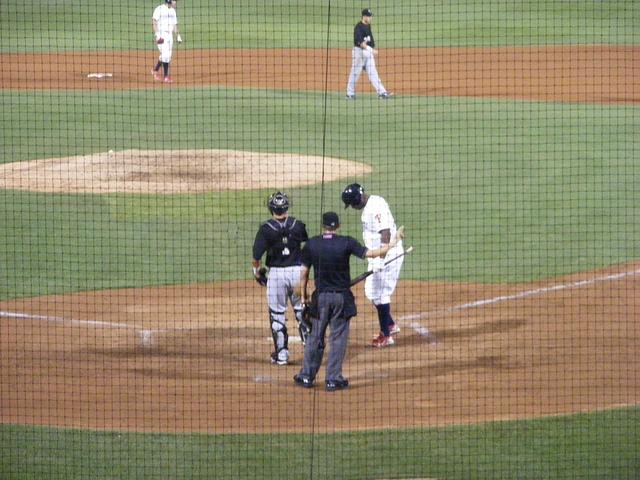What is the job of the man in the gray pants?
Quick response, please. Umpire. Was it a foul ball?
Short answer required. Yes. Is there a polka playing?
Write a very short answer. No. 